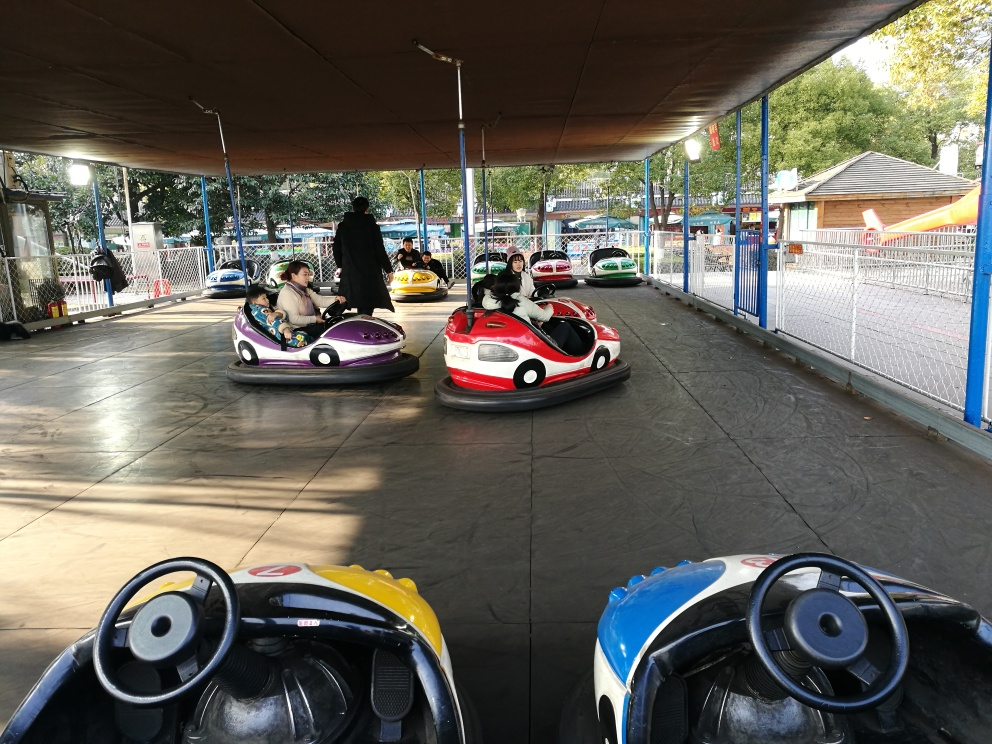Can you tell me something about the setting of this activity? Certainly! The setting appears to be an outdoor bumper car attraction. It's likely part of a larger amusement park. The ride is covered by a large canopy, providing shade for the riders. There's a visible fence surrounding the area, ensuring the safety of the riders and spectators. The presence of trees and daylight suggests this picture was taken during the day in fair weather conditions. 